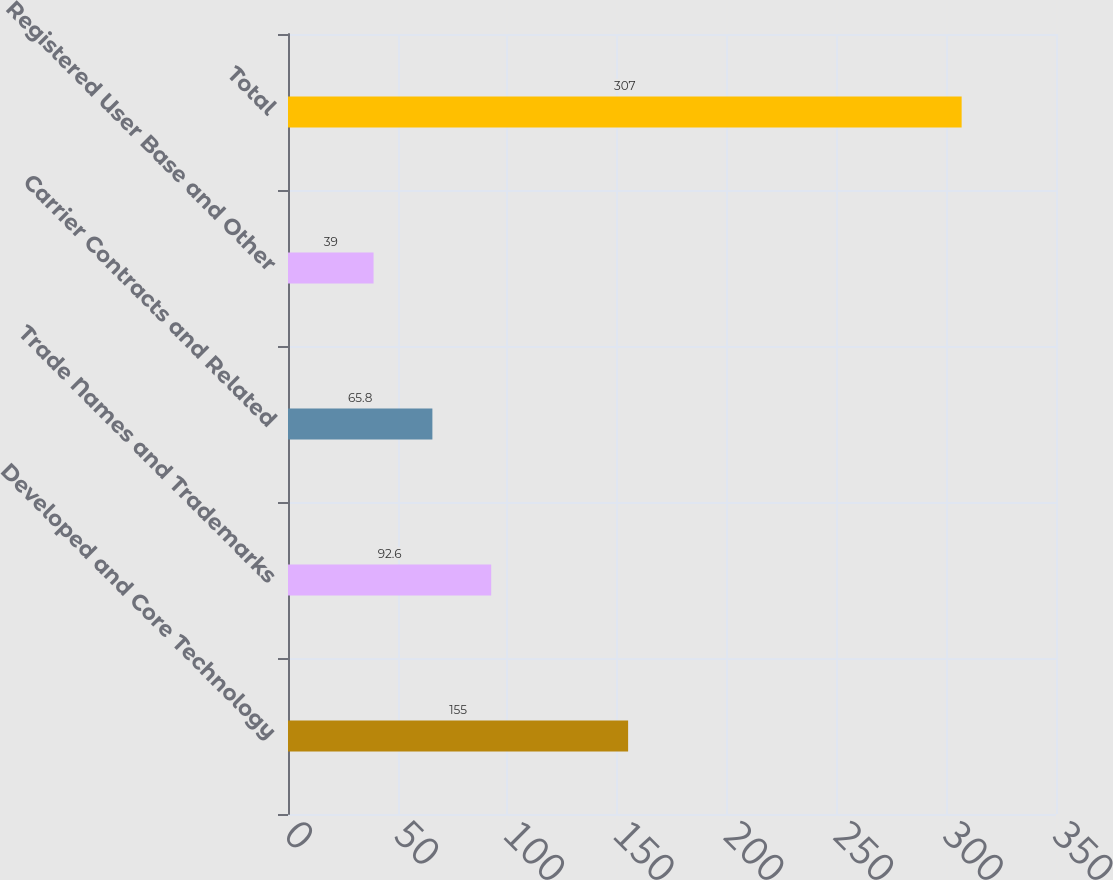Convert chart. <chart><loc_0><loc_0><loc_500><loc_500><bar_chart><fcel>Developed and Core Technology<fcel>Trade Names and Trademarks<fcel>Carrier Contracts and Related<fcel>Registered User Base and Other<fcel>Total<nl><fcel>155<fcel>92.6<fcel>65.8<fcel>39<fcel>307<nl></chart> 